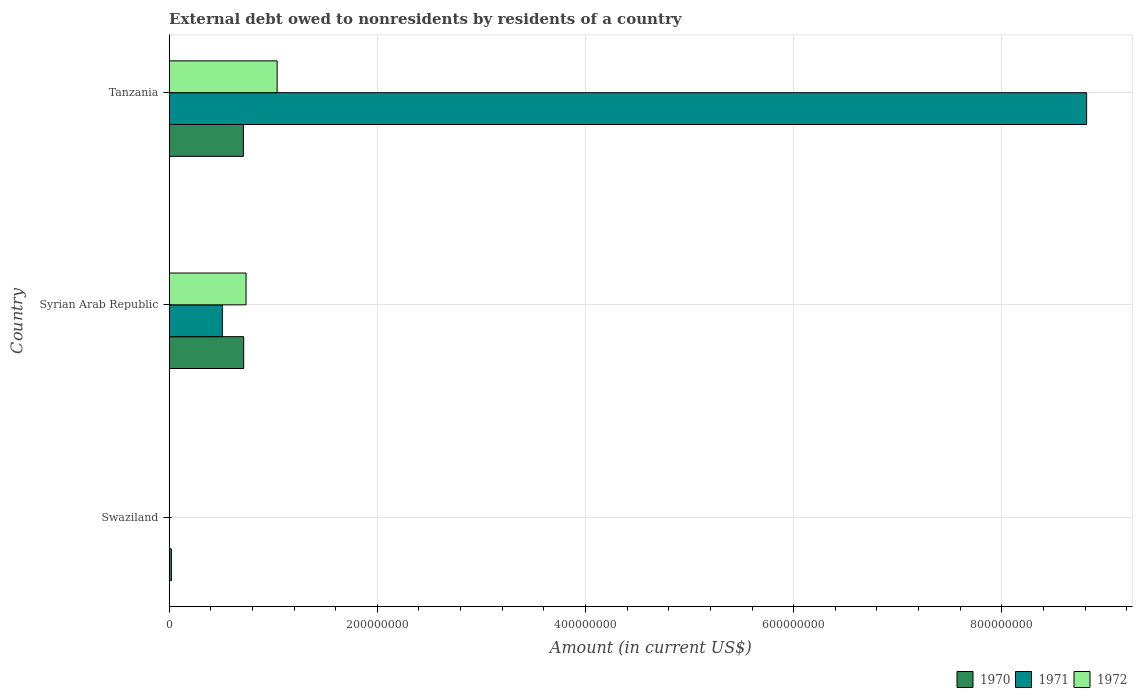How many different coloured bars are there?
Offer a very short reply. 3. What is the label of the 1st group of bars from the top?
Your answer should be very brief. Tanzania. In how many cases, is the number of bars for a given country not equal to the number of legend labels?
Your response must be concise. 1. What is the external debt owed by residents in 1970 in Swaziland?
Provide a short and direct response. 2.10e+06. Across all countries, what is the maximum external debt owed by residents in 1970?
Ensure brevity in your answer.  7.16e+07. Across all countries, what is the minimum external debt owed by residents in 1972?
Provide a succinct answer. 0. In which country was the external debt owed by residents in 1970 maximum?
Ensure brevity in your answer.  Syrian Arab Republic. What is the total external debt owed by residents in 1972 in the graph?
Offer a terse response. 1.78e+08. What is the difference between the external debt owed by residents in 1971 in Syrian Arab Republic and that in Tanzania?
Give a very brief answer. -8.30e+08. What is the difference between the external debt owed by residents in 1971 in Tanzania and the external debt owed by residents in 1972 in Swaziland?
Keep it short and to the point. 8.81e+08. What is the average external debt owed by residents in 1971 per country?
Offer a very short reply. 3.11e+08. What is the difference between the external debt owed by residents in 1970 and external debt owed by residents in 1971 in Tanzania?
Your answer should be compact. -8.10e+08. In how many countries, is the external debt owed by residents in 1972 greater than 360000000 US$?
Your answer should be compact. 0. What is the ratio of the external debt owed by residents in 1970 in Syrian Arab Republic to that in Tanzania?
Your response must be concise. 1. Is the external debt owed by residents in 1970 in Swaziland less than that in Tanzania?
Give a very brief answer. Yes. What is the difference between the highest and the second highest external debt owed by residents in 1970?
Offer a terse response. 3.21e+05. What is the difference between the highest and the lowest external debt owed by residents in 1971?
Provide a short and direct response. 8.81e+08. How many countries are there in the graph?
Offer a terse response. 3. Are the values on the major ticks of X-axis written in scientific E-notation?
Your response must be concise. No. Does the graph contain any zero values?
Provide a succinct answer. Yes. How many legend labels are there?
Provide a succinct answer. 3. How are the legend labels stacked?
Ensure brevity in your answer.  Horizontal. What is the title of the graph?
Offer a very short reply. External debt owed to nonresidents by residents of a country. What is the Amount (in current US$) of 1970 in Swaziland?
Provide a succinct answer. 2.10e+06. What is the Amount (in current US$) in 1971 in Swaziland?
Provide a succinct answer. 0. What is the Amount (in current US$) of 1972 in Swaziland?
Give a very brief answer. 0. What is the Amount (in current US$) in 1970 in Syrian Arab Republic?
Make the answer very short. 7.16e+07. What is the Amount (in current US$) in 1971 in Syrian Arab Republic?
Make the answer very short. 5.11e+07. What is the Amount (in current US$) of 1972 in Syrian Arab Republic?
Your answer should be compact. 7.38e+07. What is the Amount (in current US$) in 1970 in Tanzania?
Offer a terse response. 7.13e+07. What is the Amount (in current US$) of 1971 in Tanzania?
Offer a very short reply. 8.81e+08. What is the Amount (in current US$) in 1972 in Tanzania?
Your response must be concise. 1.04e+08. Across all countries, what is the maximum Amount (in current US$) in 1970?
Your response must be concise. 7.16e+07. Across all countries, what is the maximum Amount (in current US$) of 1971?
Your response must be concise. 8.81e+08. Across all countries, what is the maximum Amount (in current US$) of 1972?
Keep it short and to the point. 1.04e+08. Across all countries, what is the minimum Amount (in current US$) in 1970?
Provide a succinct answer. 2.10e+06. Across all countries, what is the minimum Amount (in current US$) of 1971?
Offer a terse response. 0. Across all countries, what is the minimum Amount (in current US$) in 1972?
Offer a very short reply. 0. What is the total Amount (in current US$) of 1970 in the graph?
Give a very brief answer. 1.45e+08. What is the total Amount (in current US$) in 1971 in the graph?
Keep it short and to the point. 9.33e+08. What is the total Amount (in current US$) of 1972 in the graph?
Your answer should be very brief. 1.78e+08. What is the difference between the Amount (in current US$) of 1970 in Swaziland and that in Syrian Arab Republic?
Keep it short and to the point. -6.95e+07. What is the difference between the Amount (in current US$) in 1970 in Swaziland and that in Tanzania?
Provide a short and direct response. -6.91e+07. What is the difference between the Amount (in current US$) of 1970 in Syrian Arab Republic and that in Tanzania?
Give a very brief answer. 3.21e+05. What is the difference between the Amount (in current US$) in 1971 in Syrian Arab Republic and that in Tanzania?
Keep it short and to the point. -8.30e+08. What is the difference between the Amount (in current US$) in 1972 in Syrian Arab Republic and that in Tanzania?
Your answer should be compact. -2.99e+07. What is the difference between the Amount (in current US$) in 1970 in Swaziland and the Amount (in current US$) in 1971 in Syrian Arab Republic?
Offer a very short reply. -4.90e+07. What is the difference between the Amount (in current US$) in 1970 in Swaziland and the Amount (in current US$) in 1972 in Syrian Arab Republic?
Your response must be concise. -7.17e+07. What is the difference between the Amount (in current US$) in 1970 in Swaziland and the Amount (in current US$) in 1971 in Tanzania?
Your answer should be very brief. -8.79e+08. What is the difference between the Amount (in current US$) of 1970 in Swaziland and the Amount (in current US$) of 1972 in Tanzania?
Your response must be concise. -1.02e+08. What is the difference between the Amount (in current US$) in 1970 in Syrian Arab Republic and the Amount (in current US$) in 1971 in Tanzania?
Keep it short and to the point. -8.10e+08. What is the difference between the Amount (in current US$) of 1970 in Syrian Arab Republic and the Amount (in current US$) of 1972 in Tanzania?
Provide a succinct answer. -3.21e+07. What is the difference between the Amount (in current US$) of 1971 in Syrian Arab Republic and the Amount (in current US$) of 1972 in Tanzania?
Provide a succinct answer. -5.26e+07. What is the average Amount (in current US$) in 1970 per country?
Your answer should be very brief. 4.83e+07. What is the average Amount (in current US$) in 1971 per country?
Ensure brevity in your answer.  3.11e+08. What is the average Amount (in current US$) in 1972 per country?
Keep it short and to the point. 5.92e+07. What is the difference between the Amount (in current US$) in 1970 and Amount (in current US$) in 1971 in Syrian Arab Republic?
Offer a terse response. 2.05e+07. What is the difference between the Amount (in current US$) of 1970 and Amount (in current US$) of 1972 in Syrian Arab Republic?
Your answer should be compact. -2.27e+06. What is the difference between the Amount (in current US$) of 1971 and Amount (in current US$) of 1972 in Syrian Arab Republic?
Provide a succinct answer. -2.28e+07. What is the difference between the Amount (in current US$) of 1970 and Amount (in current US$) of 1971 in Tanzania?
Your answer should be compact. -8.10e+08. What is the difference between the Amount (in current US$) of 1970 and Amount (in current US$) of 1972 in Tanzania?
Provide a short and direct response. -3.25e+07. What is the difference between the Amount (in current US$) of 1971 and Amount (in current US$) of 1972 in Tanzania?
Your answer should be very brief. 7.78e+08. What is the ratio of the Amount (in current US$) of 1970 in Swaziland to that in Syrian Arab Republic?
Provide a succinct answer. 0.03. What is the ratio of the Amount (in current US$) of 1970 in Swaziland to that in Tanzania?
Provide a succinct answer. 0.03. What is the ratio of the Amount (in current US$) of 1970 in Syrian Arab Republic to that in Tanzania?
Your answer should be compact. 1. What is the ratio of the Amount (in current US$) in 1971 in Syrian Arab Republic to that in Tanzania?
Give a very brief answer. 0.06. What is the ratio of the Amount (in current US$) in 1972 in Syrian Arab Republic to that in Tanzania?
Your answer should be compact. 0.71. What is the difference between the highest and the second highest Amount (in current US$) in 1970?
Provide a short and direct response. 3.21e+05. What is the difference between the highest and the lowest Amount (in current US$) in 1970?
Provide a short and direct response. 6.95e+07. What is the difference between the highest and the lowest Amount (in current US$) in 1971?
Make the answer very short. 8.81e+08. What is the difference between the highest and the lowest Amount (in current US$) in 1972?
Ensure brevity in your answer.  1.04e+08. 